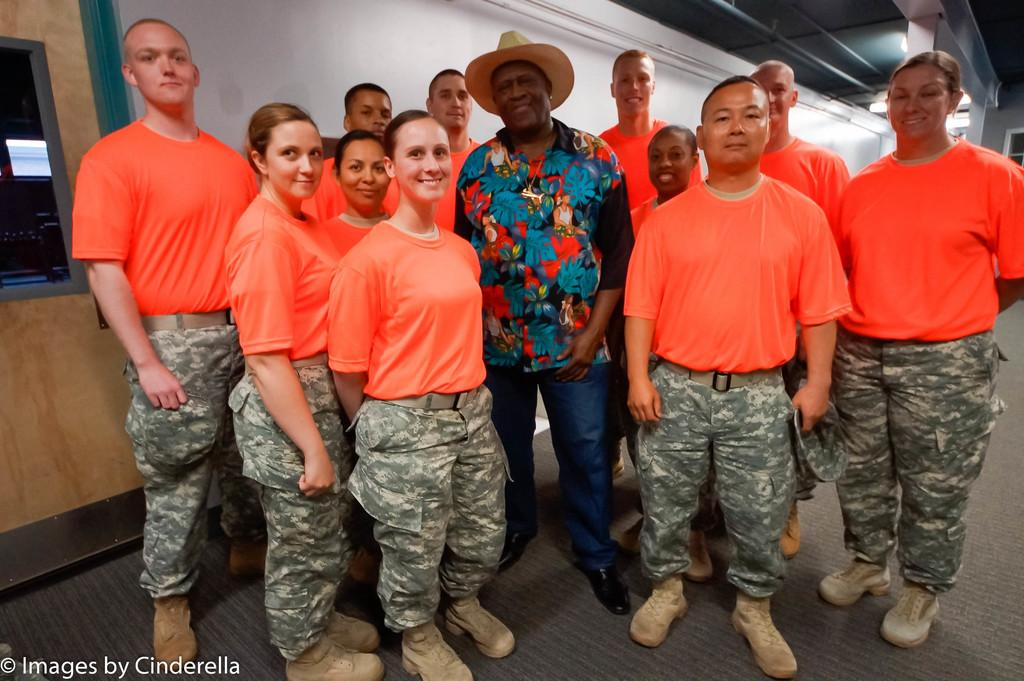What is happening in the image? There are people standing in the image. Can you describe the man standing in the center? The man standing in the center is wearing a hat. What can be seen in the background of the image? There is a wall and a door visible in the background. What type of illumination is present in the image? There are lights in the image. How many lizards can be seen crawling on the wall in the image? There are no lizards visible in the image; only people, a wall, a door, and lights are present. What type of vehicle is the man driving in the image? There is no vehicle or driving activity depicted in the image; it features people standing and a wall with a door. 